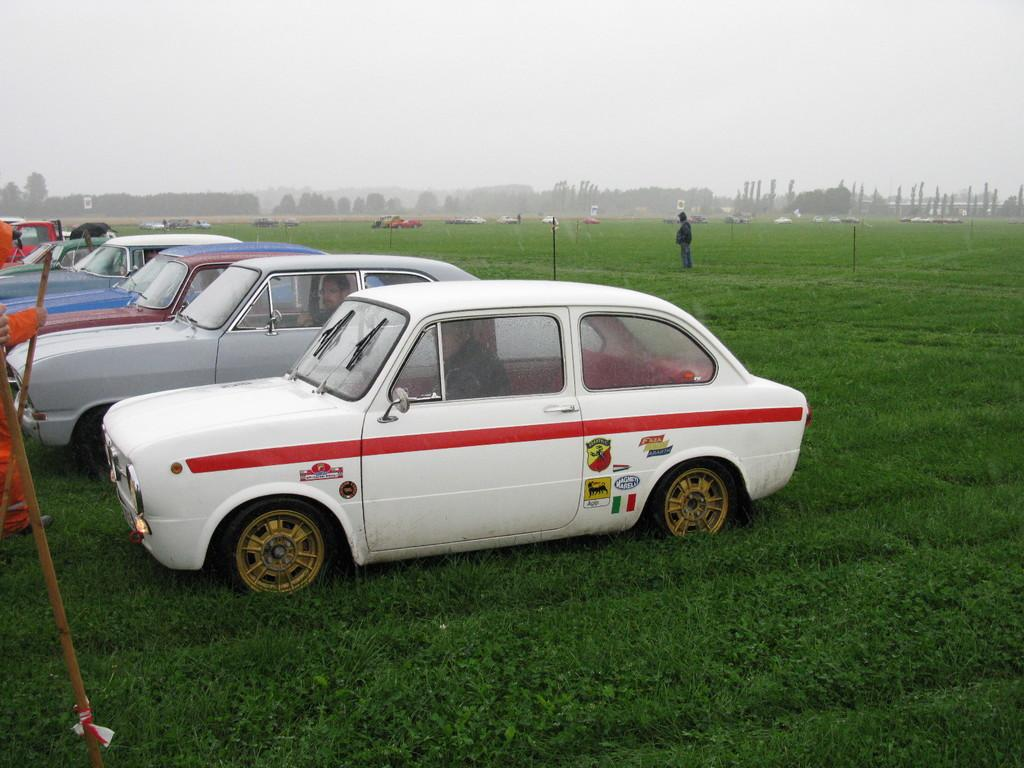What types of objects can be seen in the image? There are vehicles in the image. What can be seen on the ground in the image? There is green grass visible in the image. Can you describe the person in the image? There is a person standing on the right side of the image. What type of vegetation is present in the image? There are trees in the image. What is visible in the sky in the image? Clouds are present in the sky in the image. What type of competition is taking place in the image? There is no competition present in the image. What answer is being given by the person in the image? There is no indication of a question or answer being given in the image. 